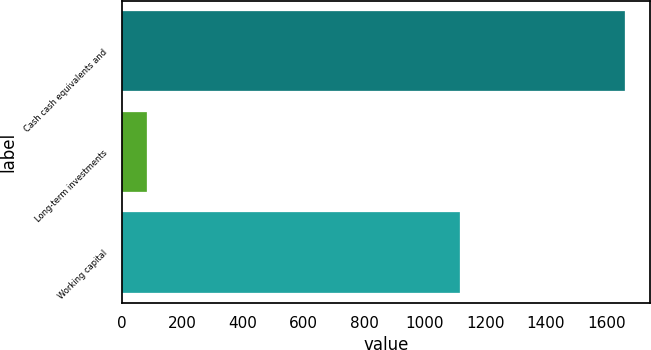<chart> <loc_0><loc_0><loc_500><loc_500><bar_chart><fcel>Cash cash equivalents and<fcel>Long-term investments<fcel>Working capital<nl><fcel>1661<fcel>83<fcel>1116<nl></chart> 